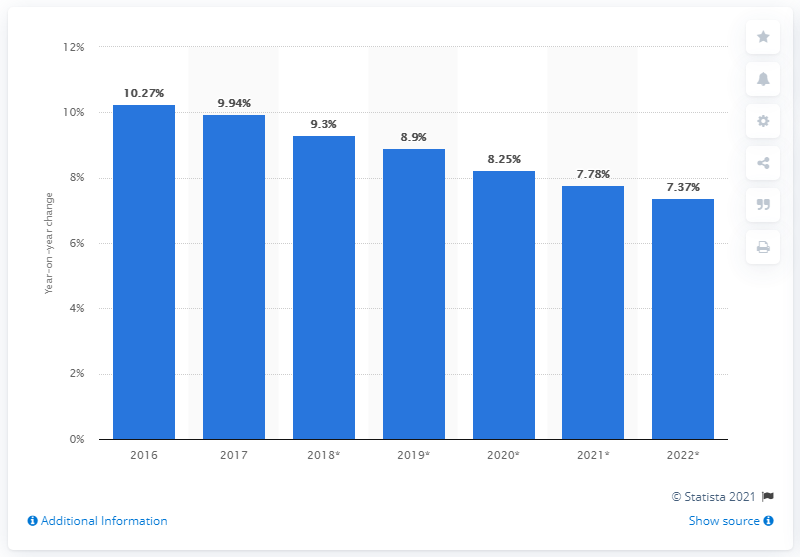Give some essential details in this illustration. The number of mobile phone internet users in Indonesia grew by 9.94% in 2017. 